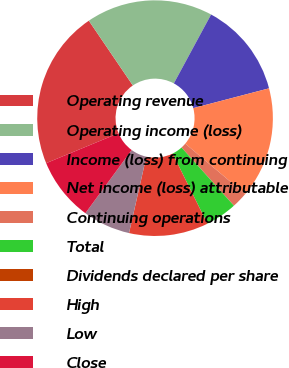<chart> <loc_0><loc_0><loc_500><loc_500><pie_chart><fcel>Operating revenue<fcel>Operating income (loss)<fcel>Income (loss) from continuing<fcel>Net income (loss) attributable<fcel>Continuing operations<fcel>Total<fcel>Dividends declared per share<fcel>High<fcel>Low<fcel>Close<nl><fcel>21.74%<fcel>17.39%<fcel>13.04%<fcel>15.22%<fcel>2.18%<fcel>4.35%<fcel>0.0%<fcel>10.87%<fcel>6.52%<fcel>8.7%<nl></chart> 